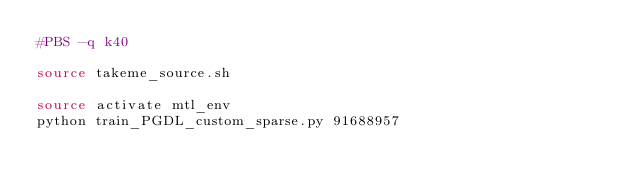Convert code to text. <code><loc_0><loc_0><loc_500><loc_500><_Bash_>#PBS -q k40 

source takeme_source.sh

source activate mtl_env
python train_PGDL_custom_sparse.py 91688957</code> 